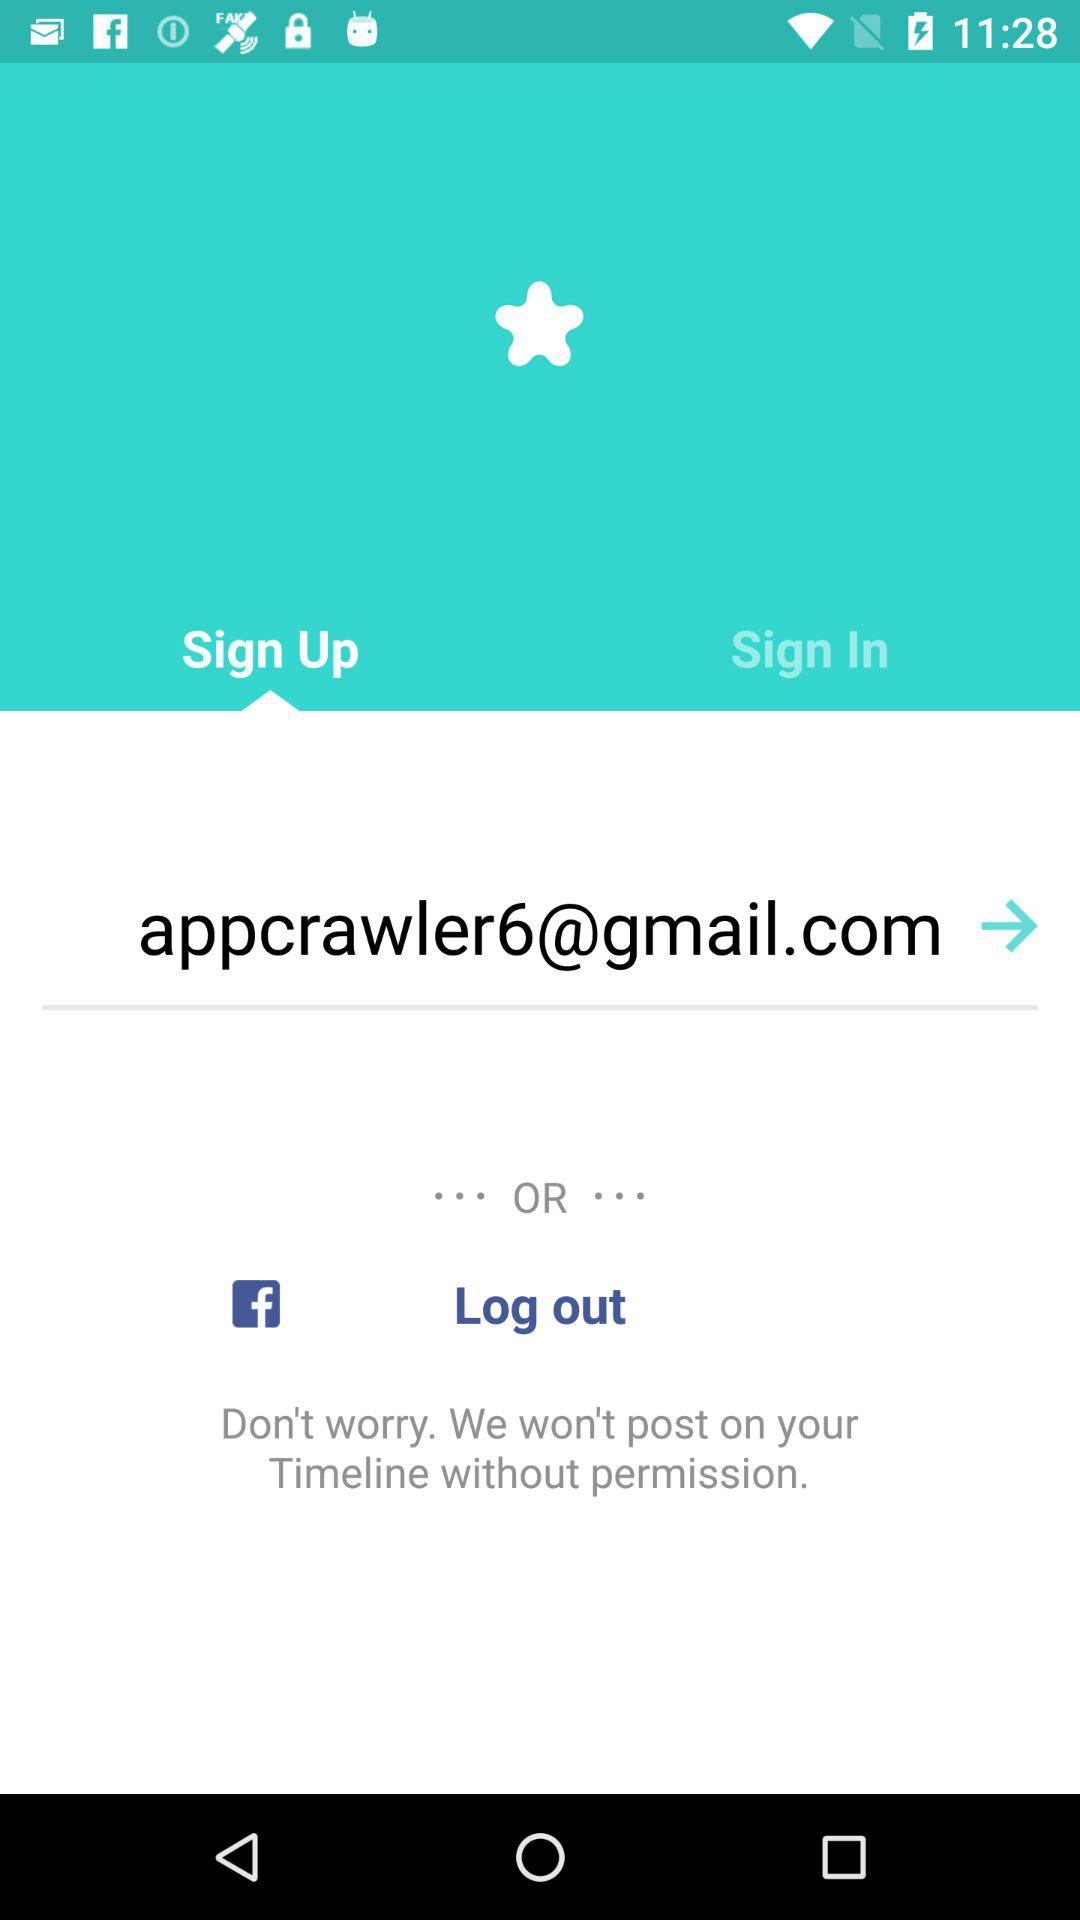What is the email address? The email address is "appcrawler6@gmail.com". 